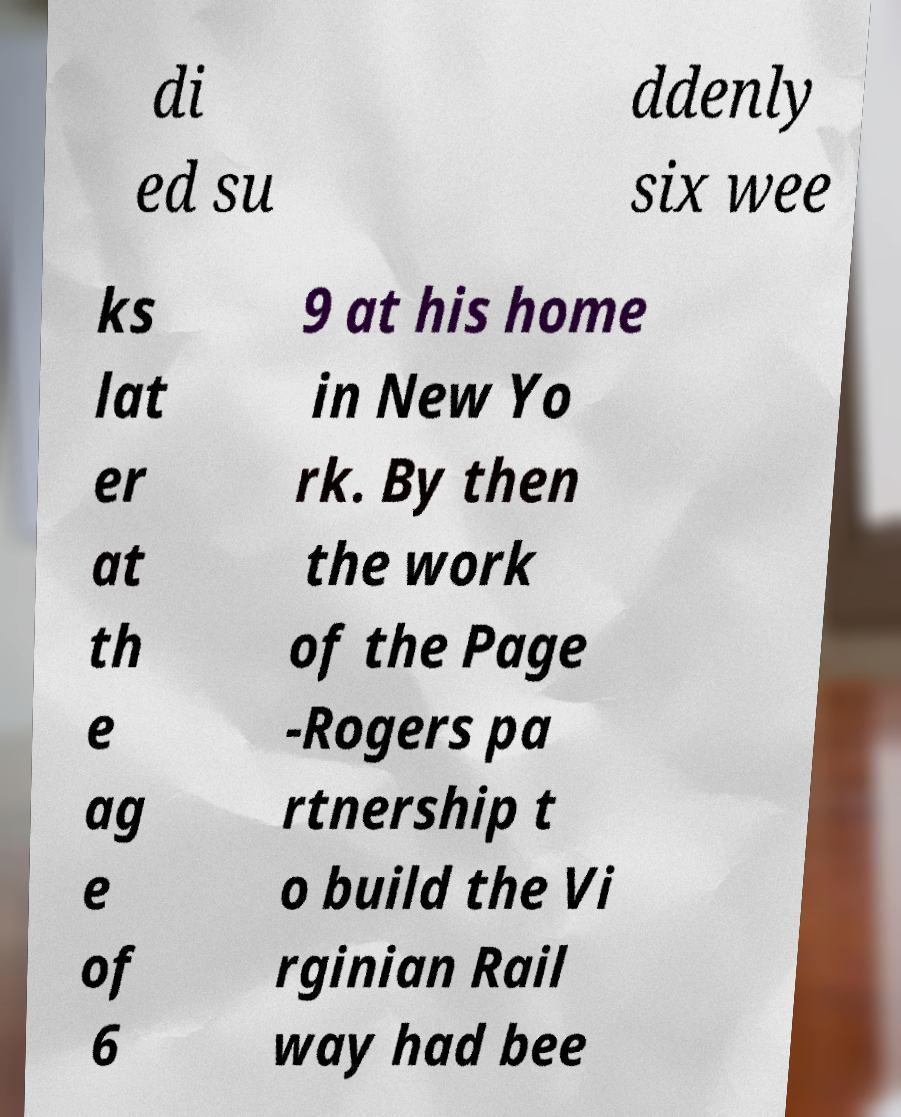I need the written content from this picture converted into text. Can you do that? di ed su ddenly six wee ks lat er at th e ag e of 6 9 at his home in New Yo rk. By then the work of the Page -Rogers pa rtnership t o build the Vi rginian Rail way had bee 